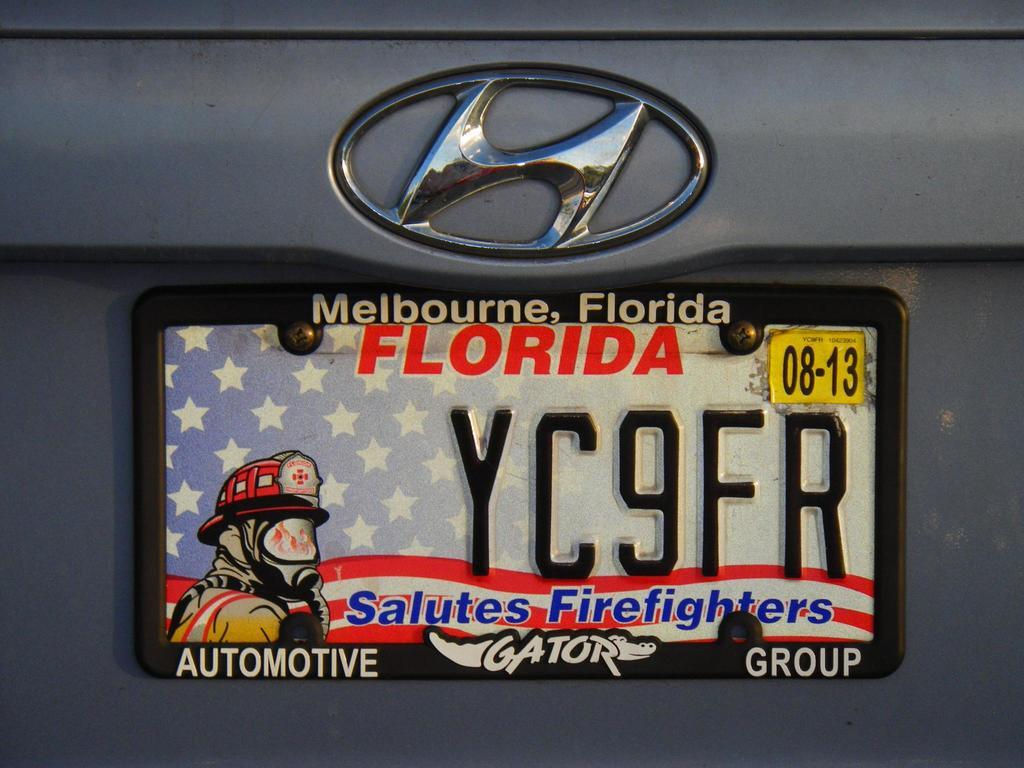What's the number of this car?
Provide a short and direct response. Yc9fr. What state is the license plate issued in?
Ensure brevity in your answer.  Florida. 